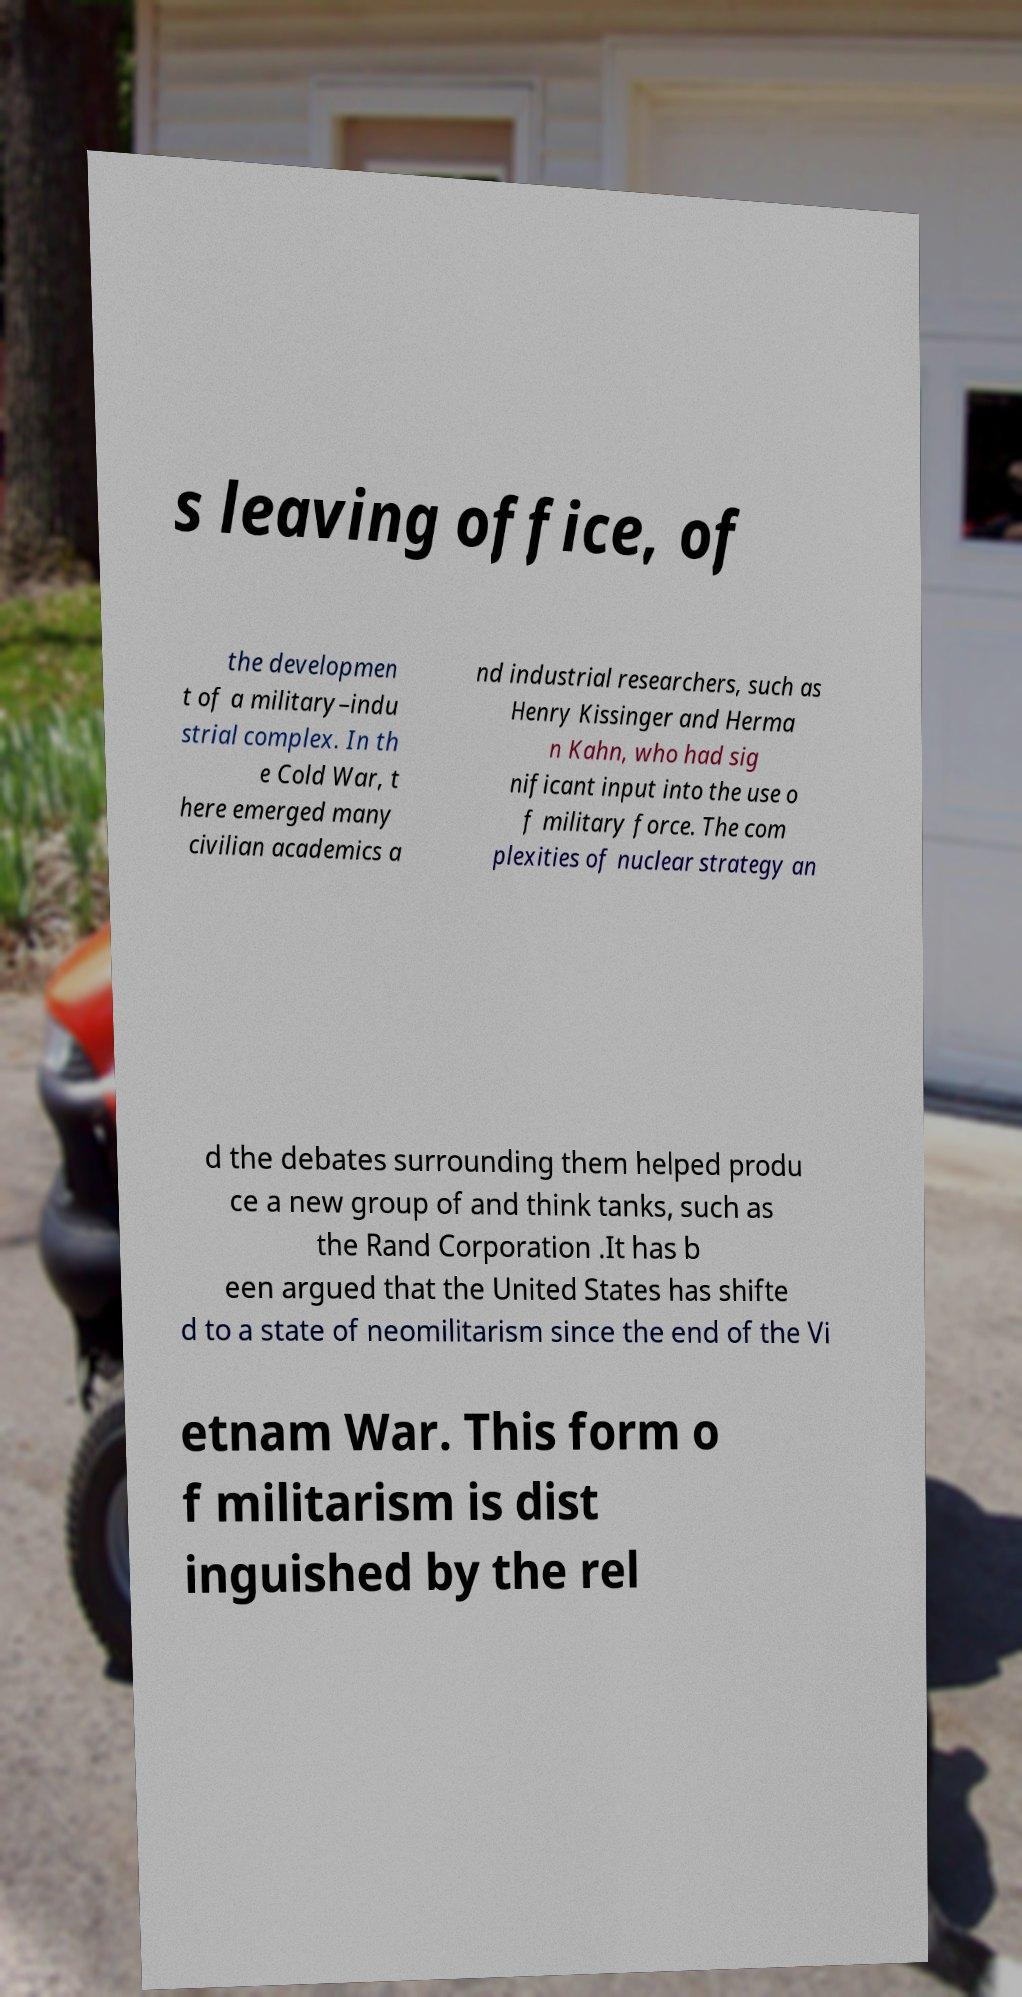There's text embedded in this image that I need extracted. Can you transcribe it verbatim? s leaving office, of the developmen t of a military–indu strial complex. In th e Cold War, t here emerged many civilian academics a nd industrial researchers, such as Henry Kissinger and Herma n Kahn, who had sig nificant input into the use o f military force. The com plexities of nuclear strategy an d the debates surrounding them helped produ ce a new group of and think tanks, such as the Rand Corporation .It has b een argued that the United States has shifte d to a state of neomilitarism since the end of the Vi etnam War. This form o f militarism is dist inguished by the rel 